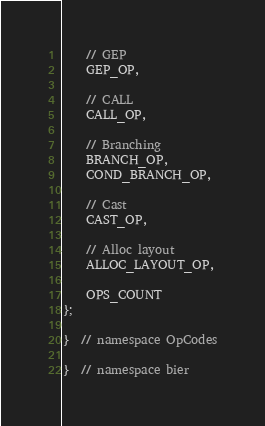Convert code to text. <code><loc_0><loc_0><loc_500><loc_500><_C_>    // GEP
    GEP_OP,

    // CALL
    CALL_OP,

    // Branching
    BRANCH_OP,
    COND_BRANCH_OP,

    // Cast
    CAST_OP,

    // Alloc layout
    ALLOC_LAYOUT_OP,

    OPS_COUNT
};

}  // namespace OpCodes

}  // namespace bier
</code> 